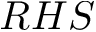<formula> <loc_0><loc_0><loc_500><loc_500>R H S</formula> 